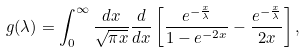Convert formula to latex. <formula><loc_0><loc_0><loc_500><loc_500>g ( \lambda ) = \int _ { 0 } ^ { \infty } \frac { d x } { \sqrt { \pi x } } \frac { d } { d x } \left [ \frac { e ^ { - \frac { x } { \lambda } } } { 1 - e ^ { - 2 x } } - \frac { e ^ { - \frac { x } { \lambda } } } { 2 x } \right ] ,</formula> 